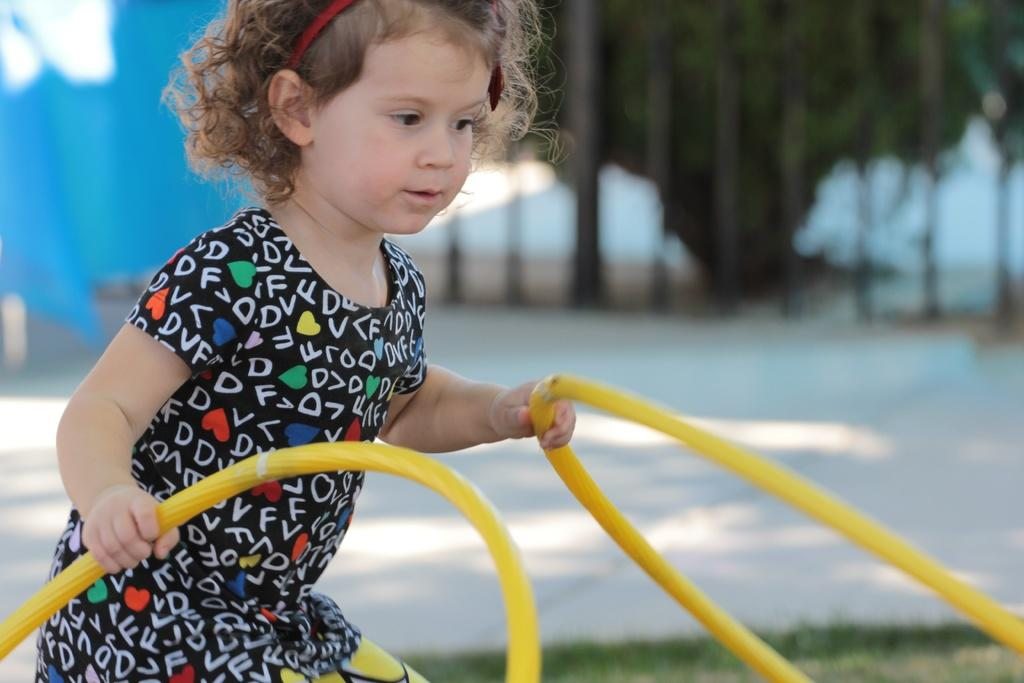Who is the main subject in the image? There is a girl in the image. What is the girl doing in the image? The girl is standing in the image. What is the girl holding in the image? The girl is holding two ropes in the image. Can you describe the background of the image? The background of the image is blurred. What time is displayed on the clock in the image? There is no clock present in the image. What is the girl arguing about with her thumb in the image? There is no argument or thumb visible in the image. 